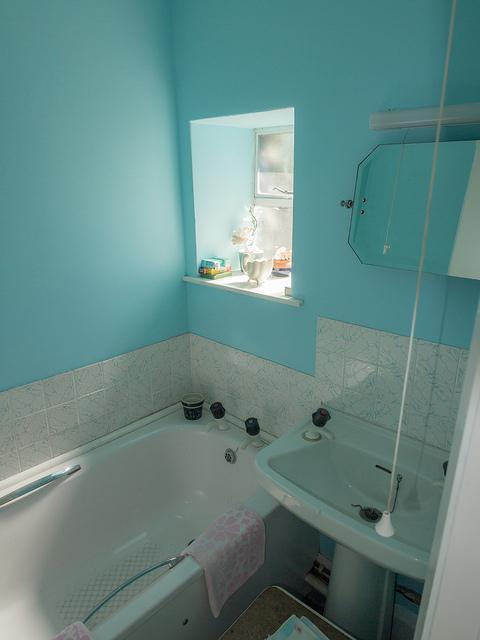How many bar of soaps are there?
Give a very brief answer. 0. How many soap dishes are on the wall?
Give a very brief answer. 0. 